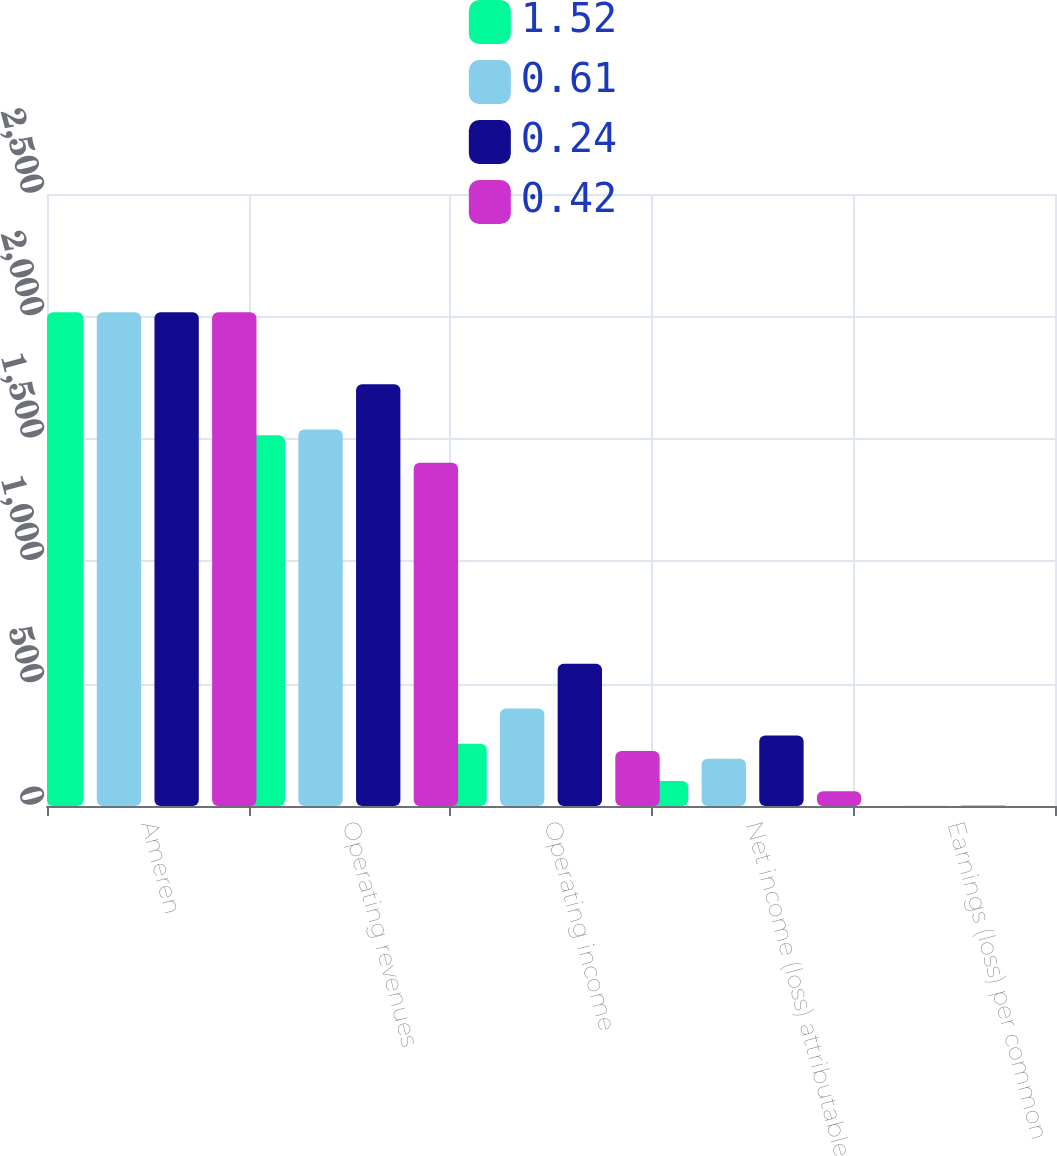Convert chart to OTSL. <chart><loc_0><loc_0><loc_500><loc_500><stacked_bar_chart><ecel><fcel>Ameren<fcel>Operating revenues<fcel>Operating income<fcel>Net income (loss) attributable<fcel>Earnings (loss) per common<nl><fcel>1.52<fcel>2017<fcel>1514<fcel>254<fcel>102<fcel>0.42<nl><fcel>0.61<fcel>2017<fcel>1538<fcel>398<fcel>193<fcel>0.79<nl><fcel>0.24<fcel>2017<fcel>1723<fcel>581<fcel>288<fcel>1.18<nl><fcel>0.42<fcel>2017<fcel>1402<fcel>225<fcel>60<fcel>0.24<nl></chart> 